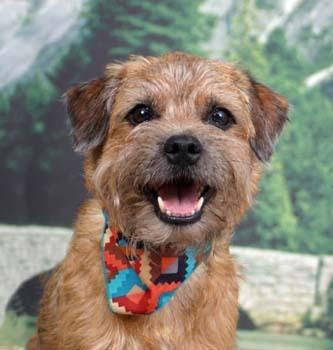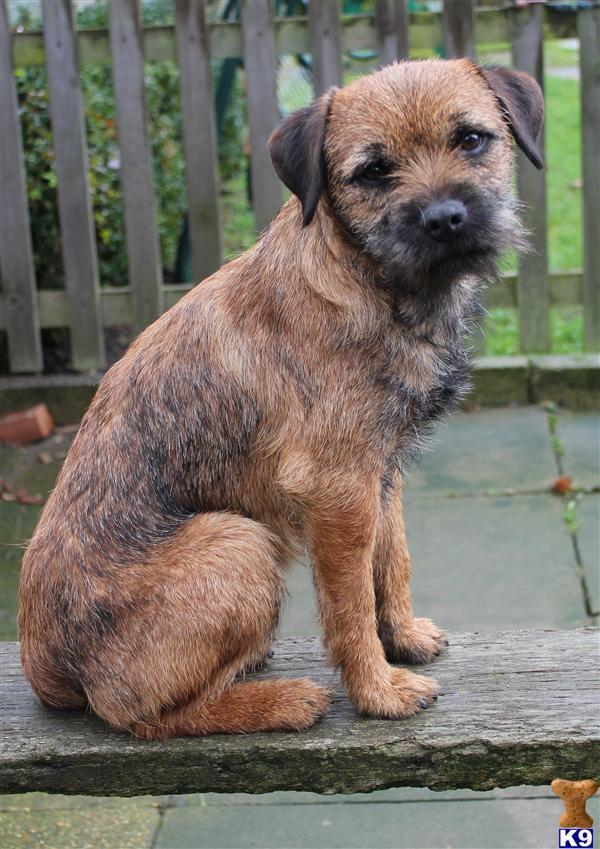The first image is the image on the left, the second image is the image on the right. Examine the images to the left and right. Is the description "A collar is visible on the dog in one of the images." accurate? Answer yes or no. Yes. 